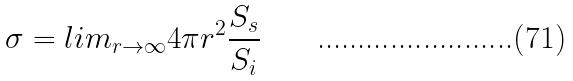Convert formula to latex. <formula><loc_0><loc_0><loc_500><loc_500>\sigma = l i m _ { r \rightarrow \infty } 4 \pi r ^ { 2 } \frac { S _ { s } } { S _ { i } }</formula> 